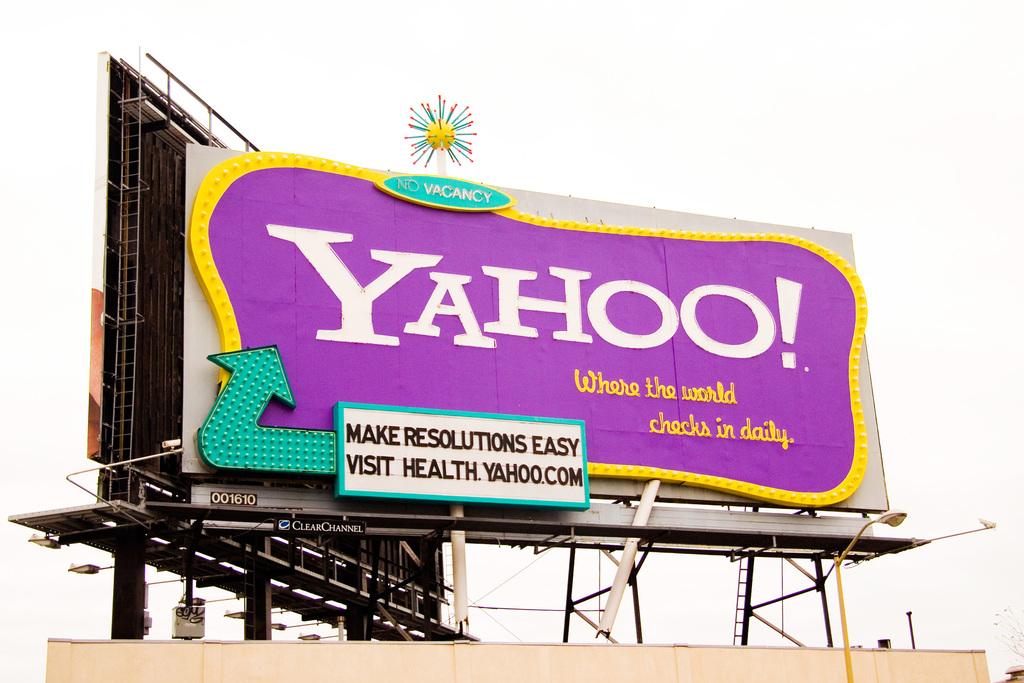What website is shown on this billboard?
Give a very brief answer. Yahoo. 